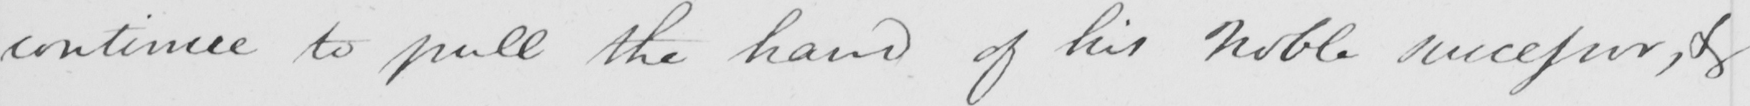Can you read and transcribe this handwriting? continue to pull the hand of his Noble successor , & 